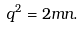Convert formula to latex. <formula><loc_0><loc_0><loc_500><loc_500>q ^ { 2 } = 2 m n .</formula> 